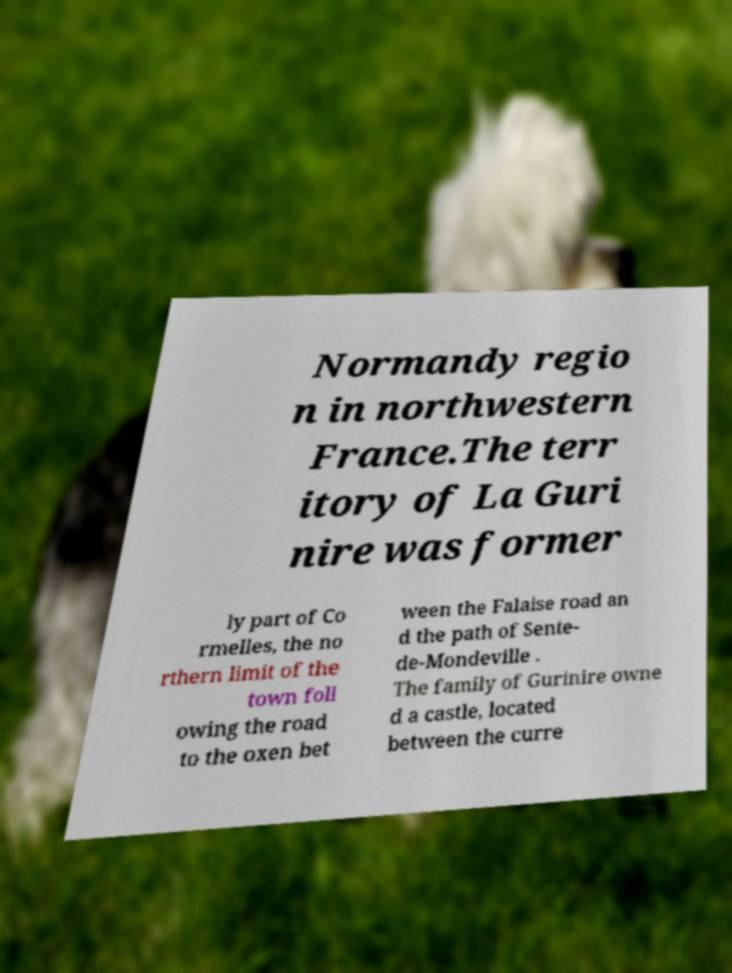Please identify and transcribe the text found in this image. Normandy regio n in northwestern France.The terr itory of La Guri nire was former ly part of Co rmelles, the no rthern limit of the town foll owing the road to the oxen bet ween the Falaise road an d the path of Sente- de-Mondeville . The family of Gurinire owne d a castle, located between the curre 